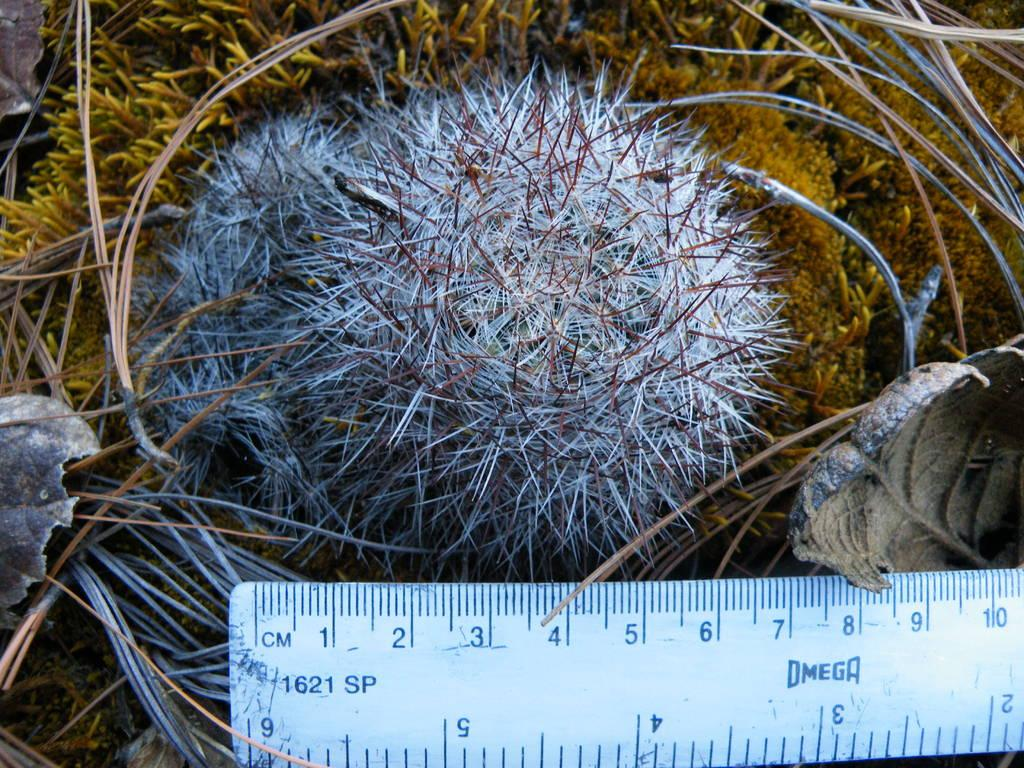<image>
Write a terse but informative summary of the picture. A 1621 SP ruler is measuring something outside. 